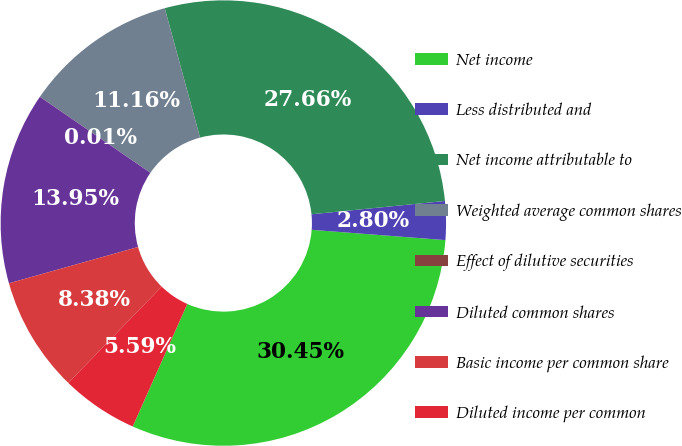Convert chart to OTSL. <chart><loc_0><loc_0><loc_500><loc_500><pie_chart><fcel>Net income<fcel>Less distributed and<fcel>Net income attributable to<fcel>Weighted average common shares<fcel>Effect of dilutive securities<fcel>Diluted common shares<fcel>Basic income per common share<fcel>Diluted income per common<nl><fcel>30.45%<fcel>2.8%<fcel>27.66%<fcel>11.16%<fcel>0.01%<fcel>13.95%<fcel>8.38%<fcel>5.59%<nl></chart> 